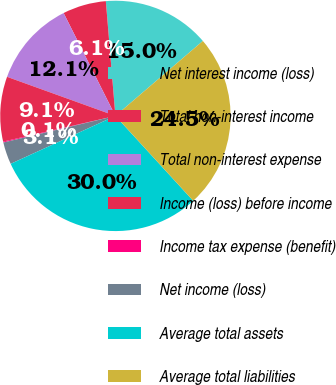Convert chart to OTSL. <chart><loc_0><loc_0><loc_500><loc_500><pie_chart><fcel>Net interest income (loss)<fcel>Total non-interest income<fcel>Total non-interest expense<fcel>Income (loss) before income<fcel>Income tax expense (benefit)<fcel>Net income (loss)<fcel>Average total assets<fcel>Average total liabilities<nl><fcel>15.05%<fcel>6.1%<fcel>12.07%<fcel>9.09%<fcel>0.13%<fcel>3.12%<fcel>29.98%<fcel>24.47%<nl></chart> 